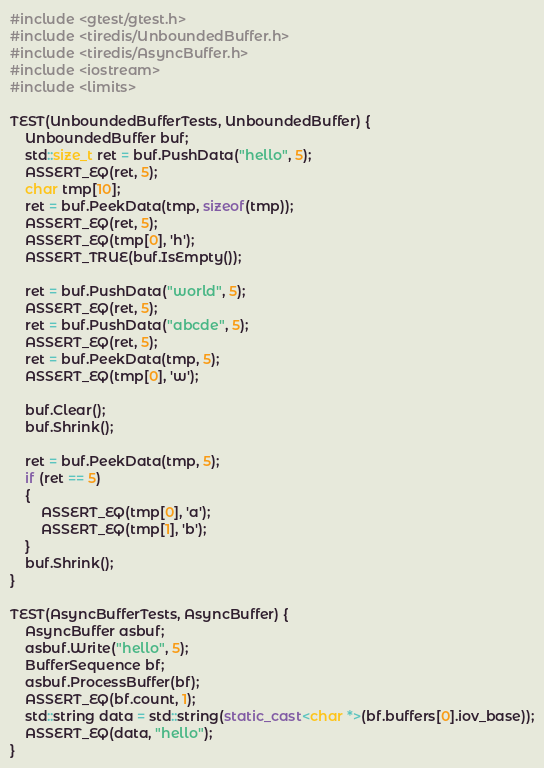Convert code to text. <code><loc_0><loc_0><loc_500><loc_500><_C++_>#include <gtest/gtest.h>
#include <tiredis/UnboundedBuffer.h>
#include <tiredis/AsyncBuffer.h>
#include <iostream>
#include <limits>

TEST(UnboundedBufferTests, UnboundedBuffer) {
    UnboundedBuffer buf;
    std::size_t ret = buf.PushData("hello", 5);
    ASSERT_EQ(ret, 5);
    char tmp[10];
    ret = buf.PeekData(tmp, sizeof(tmp));
    ASSERT_EQ(ret, 5);
    ASSERT_EQ(tmp[0], 'h');
    ASSERT_TRUE(buf.IsEmpty());

    ret = buf.PushData("world", 5);
    ASSERT_EQ(ret, 5);
    ret = buf.PushData("abcde", 5);
    ASSERT_EQ(ret, 5);
    ret = buf.PeekData(tmp, 5);
    ASSERT_EQ(tmp[0], 'w');

    buf.Clear();
    buf.Shrink();

    ret = buf.PeekData(tmp, 5);
    if (ret == 5)
    {
        ASSERT_EQ(tmp[0], 'a');
        ASSERT_EQ(tmp[1], 'b');
    }
    buf.Shrink();
}

TEST(AsyncBufferTests, AsyncBuffer) {
    AsyncBuffer asbuf;
    asbuf.Write("hello", 5);
    BufferSequence bf;
    asbuf.ProcessBuffer(bf);
    ASSERT_EQ(bf.count, 1);
    std::string data = std::string(static_cast<char *>(bf.buffers[0].iov_base));
    ASSERT_EQ(data, "hello");
}
</code> 